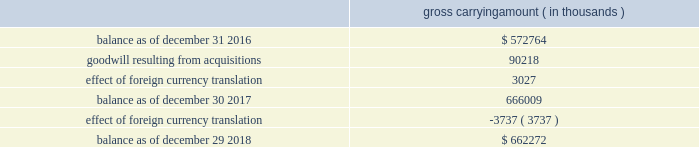Note 8 .
Acquisitions during fiscal 2017 , cadence completed two business combinations for total cash consideration of $ 142.8 million , after taking into account cash acquired of $ 4.2 million .
The total purchase consideration was allocated to the assets acquired and liabilities assumed based on their respective estimated fair values on the acquisition dates .
Cadence recorded a total of $ 76.4 million of acquired intangible assets ( of which $ 71.5 million represents in-process technology ) , $ 90.2 million of goodwill and $ 19.6 million of net liabilities consisting primarily of deferred tax liabilities .
Cadence will also make payments to certain employees , subject to continued employment and other performance-based conditions , through the fourth quarter of fiscal 2020 .
During fiscal 2016 , cadence completed two business combinations for total cash consideration of $ 42.4 million , after taking into account cash acquired of $ 1.8 million .
The total purchase consideration was allocated to the assets acquired and liabilities assumed based on their respective estimated fair values on the acquisition dates .
Cadence recorded a total of $ 23.6 million of goodwill , $ 23.2 million of acquired intangible assets and $ 2.6 million of net liabilities consisting primarily of deferred revenue .
Cadence will also make payments to certain employees , subject to continued employment and other conditions , through the second quarter of fiscal a trust for the benefit of the children of lip-bu tan , cadence 2019s chief executive officer ( 201cceo 201d ) and director , owned less than 3% ( 3 % ) of nusemi inc , one of the companies acquired in 2017 , and less than 2% ( 2 % ) of rocketick technologies ltd. , one of the companies acquired in 2016 .
Mr .
Tan and his wife serve as co-trustees of the trust and disclaim pecuniary and economic interest in the trust .
The board of directors of cadence reviewed the transactions and concluded that it was in the best interests of cadence to proceed with the transactions .
Mr .
Tan recused himself from the board of directors 2019 discussion of the valuation of nusemi inc and rocketick technologies ltd .
And on whether to proceed with the transactions .
Acquisition-related transaction costs there were no direct transaction costs associated with acquisitions during fiscal 2018 .
Transaction costs associated with acquisitions were $ 0.6 million and $ 1.1 million during fiscal 2017 and 2016 , respectively .
These costs consist of professional fees and administrative costs and were expensed as incurred in cadence 2019s consolidated income statements .
Note 9 .
Goodwill and acquired intangibles goodwill the changes in the carrying amount of goodwill during fiscal 2018 and 2017 were as follows : gross carrying amount ( in thousands ) .
Cadence completed its annual goodwill impairment test during the third quarter of fiscal 2018 and determined that the fair value of cadence 2019s single reporting unit substantially exceeded the carrying amount of its net assets and that no impairment existed. .
For acquisitions in 2017 what percentage of recorded a total acquired intangible assets was goodwill? 
Computations: (76.4 / 90.2)
Answer: 0.84701. 